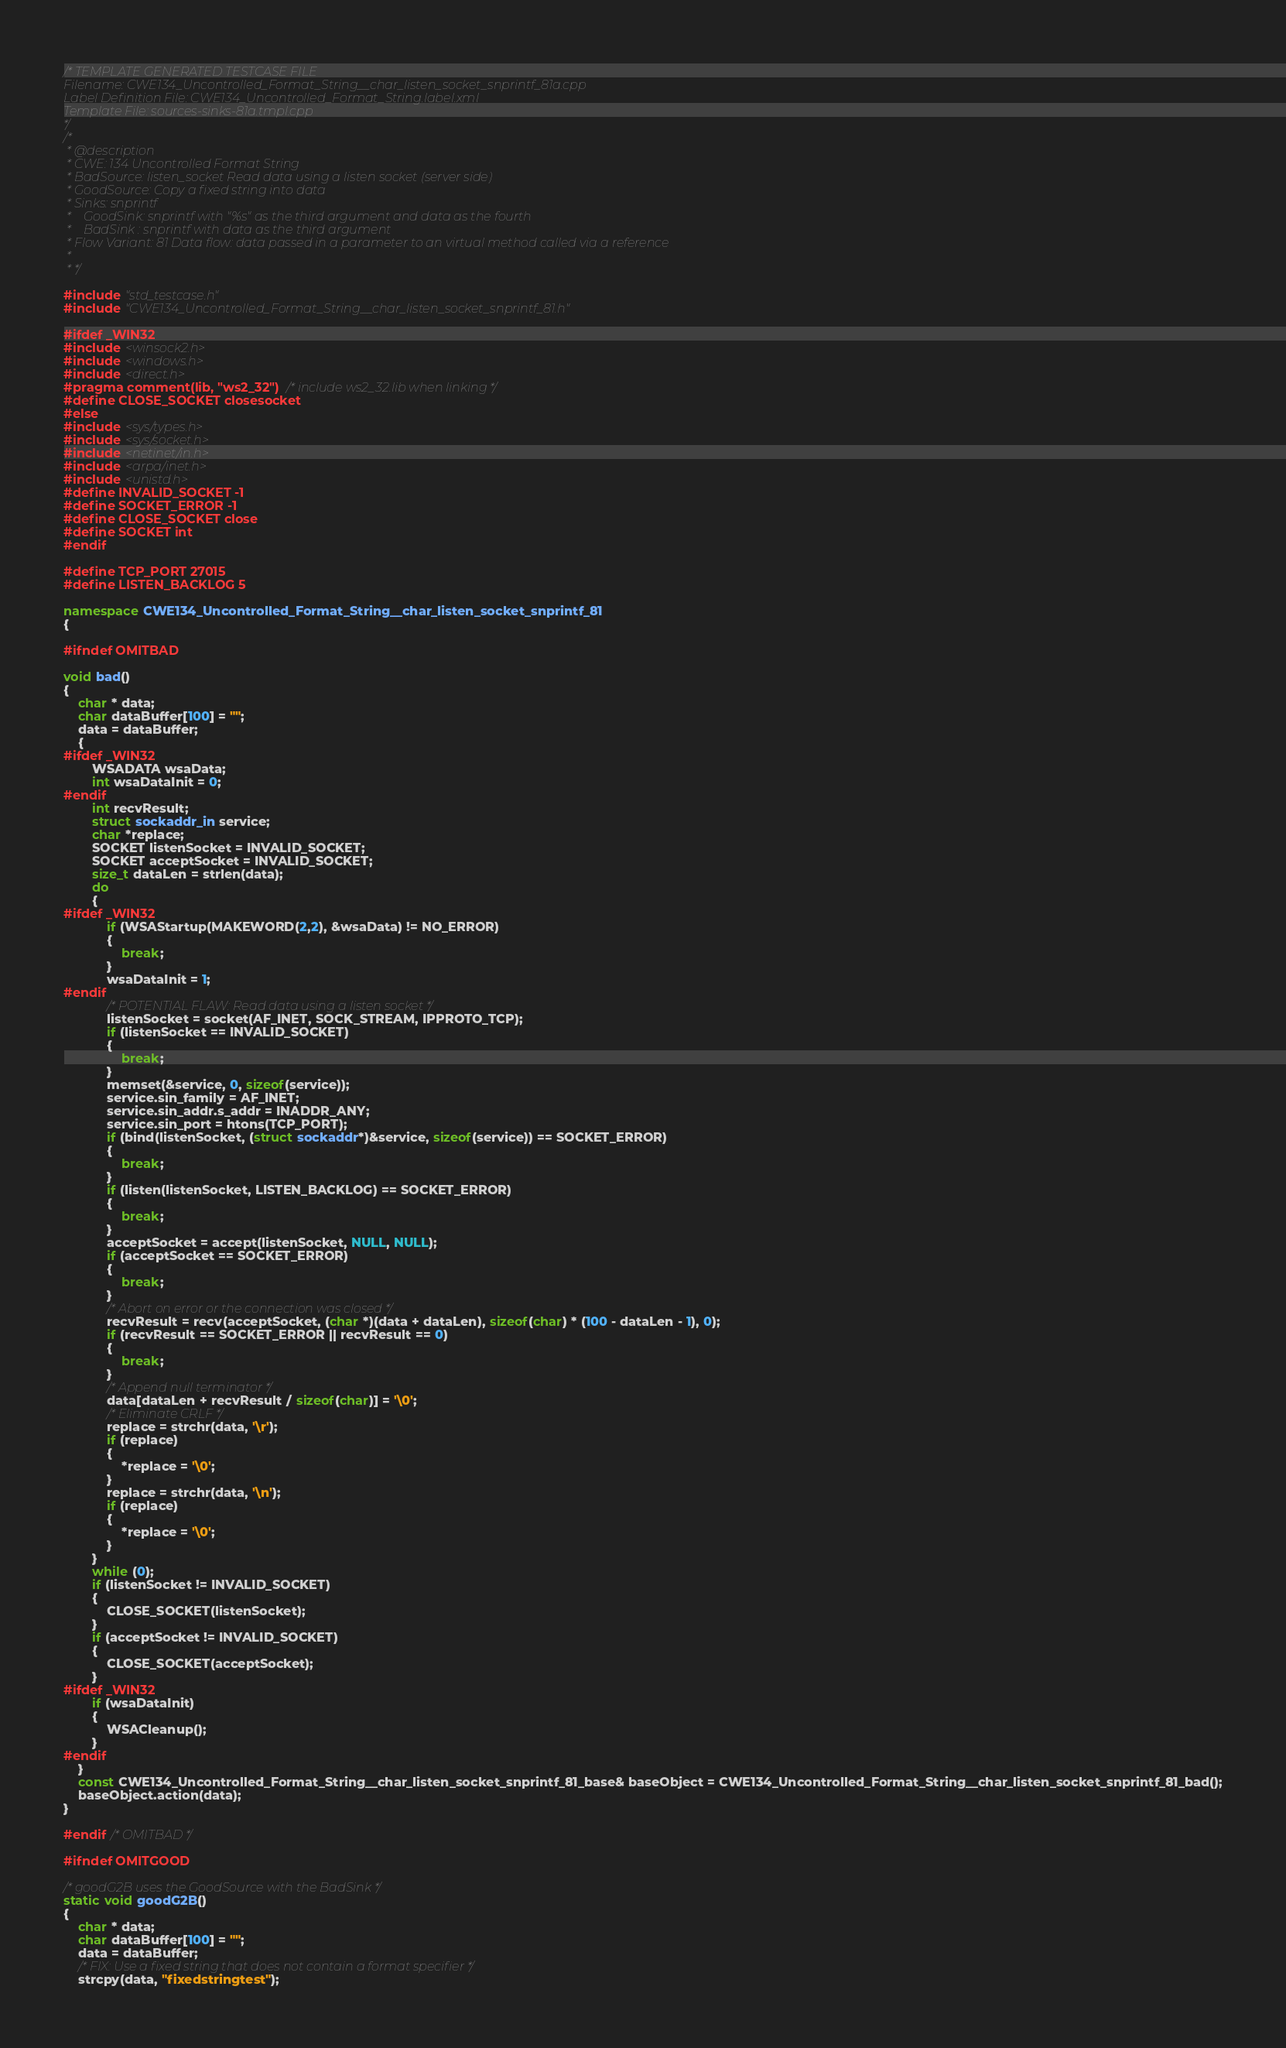<code> <loc_0><loc_0><loc_500><loc_500><_C++_>/* TEMPLATE GENERATED TESTCASE FILE
Filename: CWE134_Uncontrolled_Format_String__char_listen_socket_snprintf_81a.cpp
Label Definition File: CWE134_Uncontrolled_Format_String.label.xml
Template File: sources-sinks-81a.tmpl.cpp
*/
/*
 * @description
 * CWE: 134 Uncontrolled Format String
 * BadSource: listen_socket Read data using a listen socket (server side)
 * GoodSource: Copy a fixed string into data
 * Sinks: snprintf
 *    GoodSink: snprintf with "%s" as the third argument and data as the fourth
 *    BadSink : snprintf with data as the third argument
 * Flow Variant: 81 Data flow: data passed in a parameter to an virtual method called via a reference
 *
 * */

#include "std_testcase.h"
#include "CWE134_Uncontrolled_Format_String__char_listen_socket_snprintf_81.h"

#ifdef _WIN32
#include <winsock2.h>
#include <windows.h>
#include <direct.h>
#pragma comment(lib, "ws2_32") /* include ws2_32.lib when linking */
#define CLOSE_SOCKET closesocket
#else
#include <sys/types.h>
#include <sys/socket.h>
#include <netinet/in.h>
#include <arpa/inet.h>
#include <unistd.h>
#define INVALID_SOCKET -1
#define SOCKET_ERROR -1
#define CLOSE_SOCKET close
#define SOCKET int
#endif

#define TCP_PORT 27015
#define LISTEN_BACKLOG 5

namespace CWE134_Uncontrolled_Format_String__char_listen_socket_snprintf_81
{

#ifndef OMITBAD

void bad()
{
    char * data;
    char dataBuffer[100] = "";
    data = dataBuffer;
    {
#ifdef _WIN32
        WSADATA wsaData;
        int wsaDataInit = 0;
#endif
        int recvResult;
        struct sockaddr_in service;
        char *replace;
        SOCKET listenSocket = INVALID_SOCKET;
        SOCKET acceptSocket = INVALID_SOCKET;
        size_t dataLen = strlen(data);
        do
        {
#ifdef _WIN32
            if (WSAStartup(MAKEWORD(2,2), &wsaData) != NO_ERROR)
            {
                break;
            }
            wsaDataInit = 1;
#endif
            /* POTENTIAL FLAW: Read data using a listen socket */
            listenSocket = socket(AF_INET, SOCK_STREAM, IPPROTO_TCP);
            if (listenSocket == INVALID_SOCKET)
            {
                break;
            }
            memset(&service, 0, sizeof(service));
            service.sin_family = AF_INET;
            service.sin_addr.s_addr = INADDR_ANY;
            service.sin_port = htons(TCP_PORT);
            if (bind(listenSocket, (struct sockaddr*)&service, sizeof(service)) == SOCKET_ERROR)
            {
                break;
            }
            if (listen(listenSocket, LISTEN_BACKLOG) == SOCKET_ERROR)
            {
                break;
            }
            acceptSocket = accept(listenSocket, NULL, NULL);
            if (acceptSocket == SOCKET_ERROR)
            {
                break;
            }
            /* Abort on error or the connection was closed */
            recvResult = recv(acceptSocket, (char *)(data + dataLen), sizeof(char) * (100 - dataLen - 1), 0);
            if (recvResult == SOCKET_ERROR || recvResult == 0)
            {
                break;
            }
            /* Append null terminator */
            data[dataLen + recvResult / sizeof(char)] = '\0';
            /* Eliminate CRLF */
            replace = strchr(data, '\r');
            if (replace)
            {
                *replace = '\0';
            }
            replace = strchr(data, '\n');
            if (replace)
            {
                *replace = '\0';
            }
        }
        while (0);
        if (listenSocket != INVALID_SOCKET)
        {
            CLOSE_SOCKET(listenSocket);
        }
        if (acceptSocket != INVALID_SOCKET)
        {
            CLOSE_SOCKET(acceptSocket);
        }
#ifdef _WIN32
        if (wsaDataInit)
        {
            WSACleanup();
        }
#endif
    }
    const CWE134_Uncontrolled_Format_String__char_listen_socket_snprintf_81_base& baseObject = CWE134_Uncontrolled_Format_String__char_listen_socket_snprintf_81_bad();
    baseObject.action(data);
}

#endif /* OMITBAD */

#ifndef OMITGOOD

/* goodG2B uses the GoodSource with the BadSink */
static void goodG2B()
{
    char * data;
    char dataBuffer[100] = "";
    data = dataBuffer;
    /* FIX: Use a fixed string that does not contain a format specifier */
    strcpy(data, "fixedstringtest");</code> 